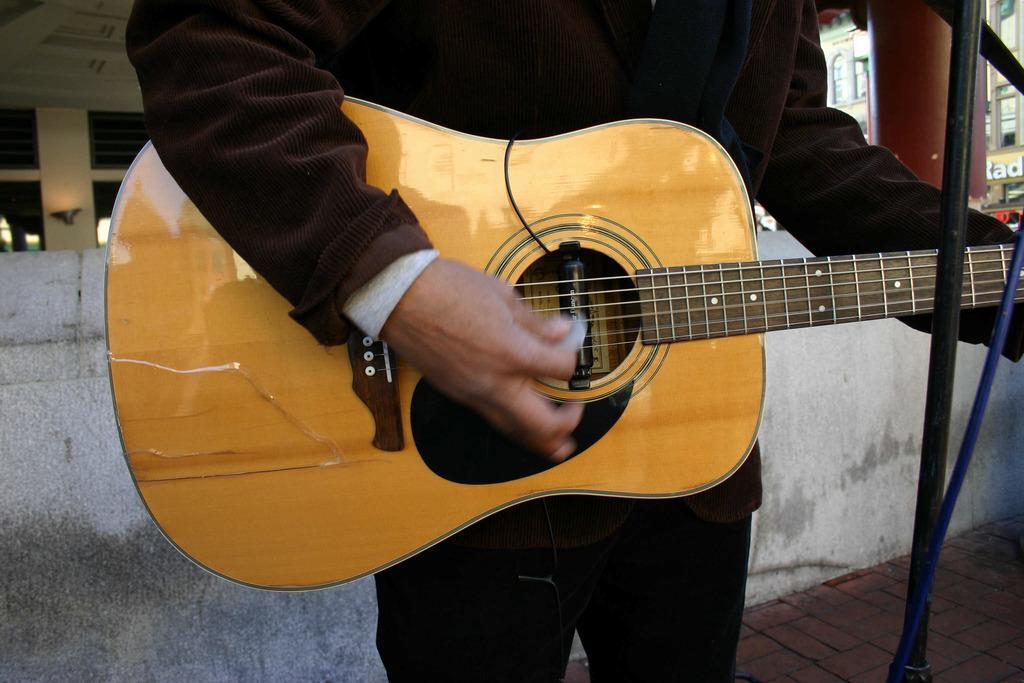Could you give a brief overview of what you see in this image? This guitar is highlighted in this picture. A person is playing a guitar. Far there is a building with windows. 